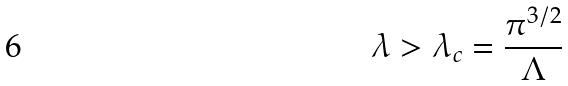Convert formula to latex. <formula><loc_0><loc_0><loc_500><loc_500>\lambda > \lambda _ { c } = \frac { \pi ^ { 3 / 2 } } { \Lambda }</formula> 